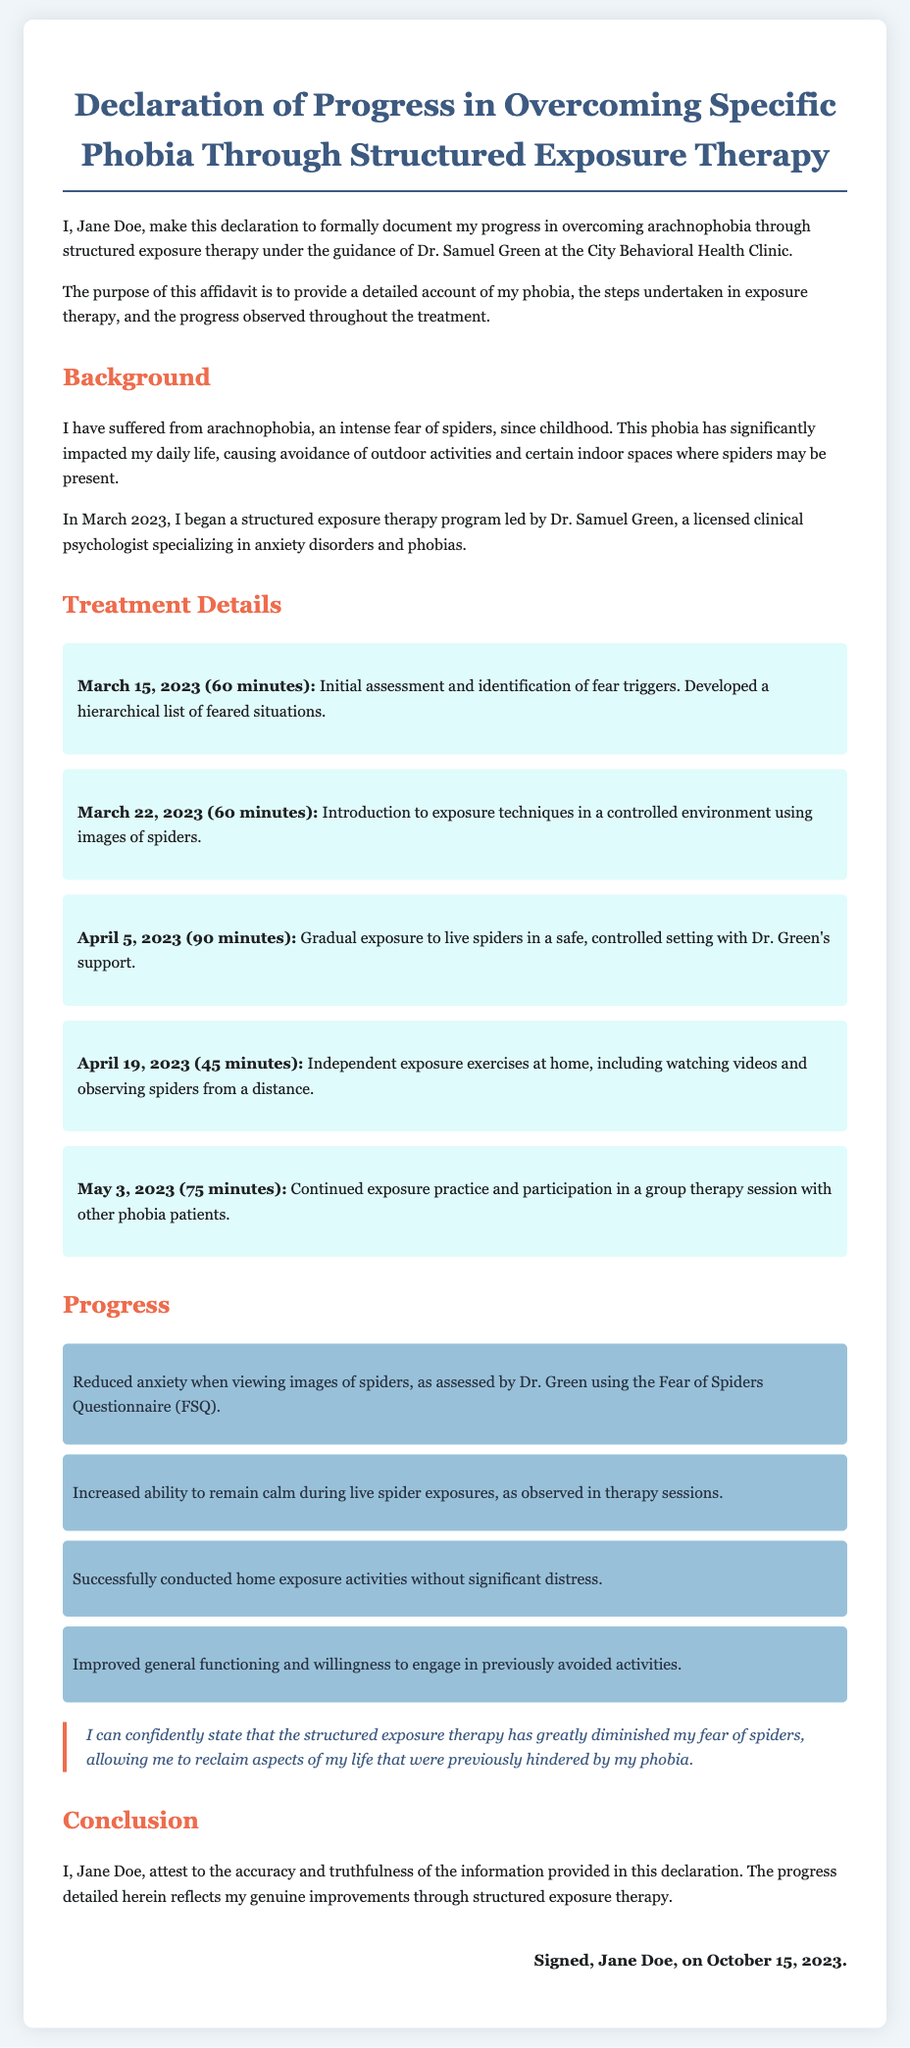What is the patient's name? The name of the patient declared in the document is mentioned at the beginning.
Answer: Jane Doe What specific phobia is addressed in the document? The phobia that the patient has suffered from is clearly stated in the background section.
Answer: Arachnophobia Who is the therapist? The document specifies the therapist's name as part of the declaration.
Answer: Dr. Samuel Green When did the patient begin the exposure therapy? The starting date of the therapy is given in the background section.
Answer: March 2023 What was the duration of the first therapy session? The length of the first session is included in the treatment details section.
Answer: 60 minutes How many therapy sessions are documented? The total number of therapy sessions is determined by counting the individual sessions listed.
Answer: Five What is the primary method used in treatment? The method of treatment discussed is highlighted in the document.
Answer: Structured exposure therapy What significant improvement was noted with images of spiders? One specific improvement related to the handling of images is provided in the progress section.
Answer: Reduced anxiety What date was the affidavit signed? The date of the affidavit signing is specified at the end of the document.
Answer: October 15, 2023 What is the overall message given by the patient in the testimonial? The patient’s overall sentiment about the therapy is summarized in the testimonial section.
Answer: Greatly diminished fear of spiders 